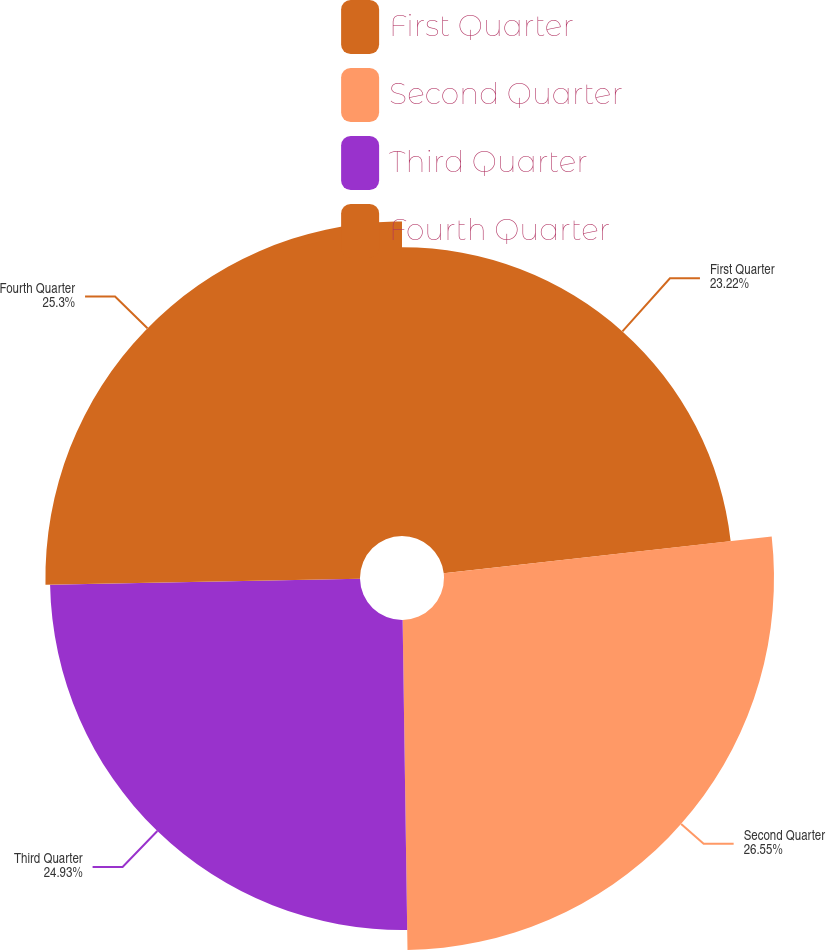<chart> <loc_0><loc_0><loc_500><loc_500><pie_chart><fcel>First Quarter<fcel>Second Quarter<fcel>Third Quarter<fcel>Fourth Quarter<nl><fcel>23.22%<fcel>26.54%<fcel>24.93%<fcel>25.3%<nl></chart> 